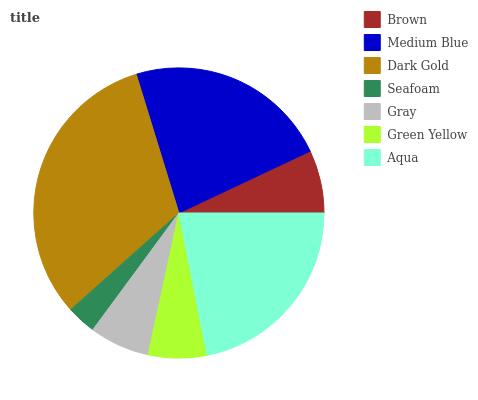Is Seafoam the minimum?
Answer yes or no. Yes. Is Dark Gold the maximum?
Answer yes or no. Yes. Is Medium Blue the minimum?
Answer yes or no. No. Is Medium Blue the maximum?
Answer yes or no. No. Is Medium Blue greater than Brown?
Answer yes or no. Yes. Is Brown less than Medium Blue?
Answer yes or no. Yes. Is Brown greater than Medium Blue?
Answer yes or no. No. Is Medium Blue less than Brown?
Answer yes or no. No. Is Brown the high median?
Answer yes or no. Yes. Is Brown the low median?
Answer yes or no. Yes. Is Medium Blue the high median?
Answer yes or no. No. Is Dark Gold the low median?
Answer yes or no. No. 